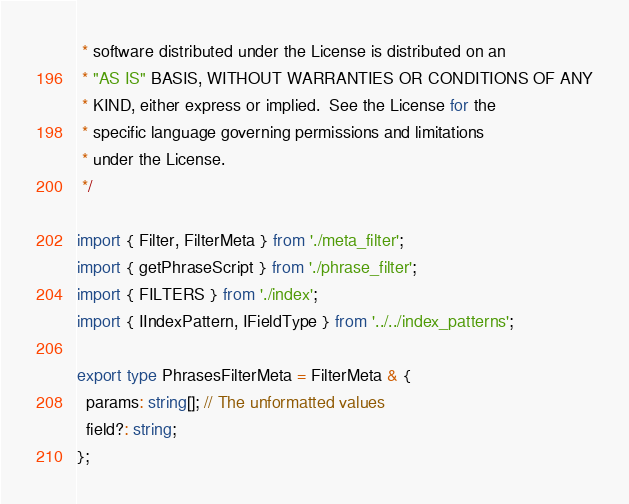<code> <loc_0><loc_0><loc_500><loc_500><_TypeScript_> * software distributed under the License is distributed on an
 * "AS IS" BASIS, WITHOUT WARRANTIES OR CONDITIONS OF ANY
 * KIND, either express or implied.  See the License for the
 * specific language governing permissions and limitations
 * under the License.
 */

import { Filter, FilterMeta } from './meta_filter';
import { getPhraseScript } from './phrase_filter';
import { FILTERS } from './index';
import { IIndexPattern, IFieldType } from '../../index_patterns';

export type PhrasesFilterMeta = FilterMeta & {
  params: string[]; // The unformatted values
  field?: string;
};
</code> 